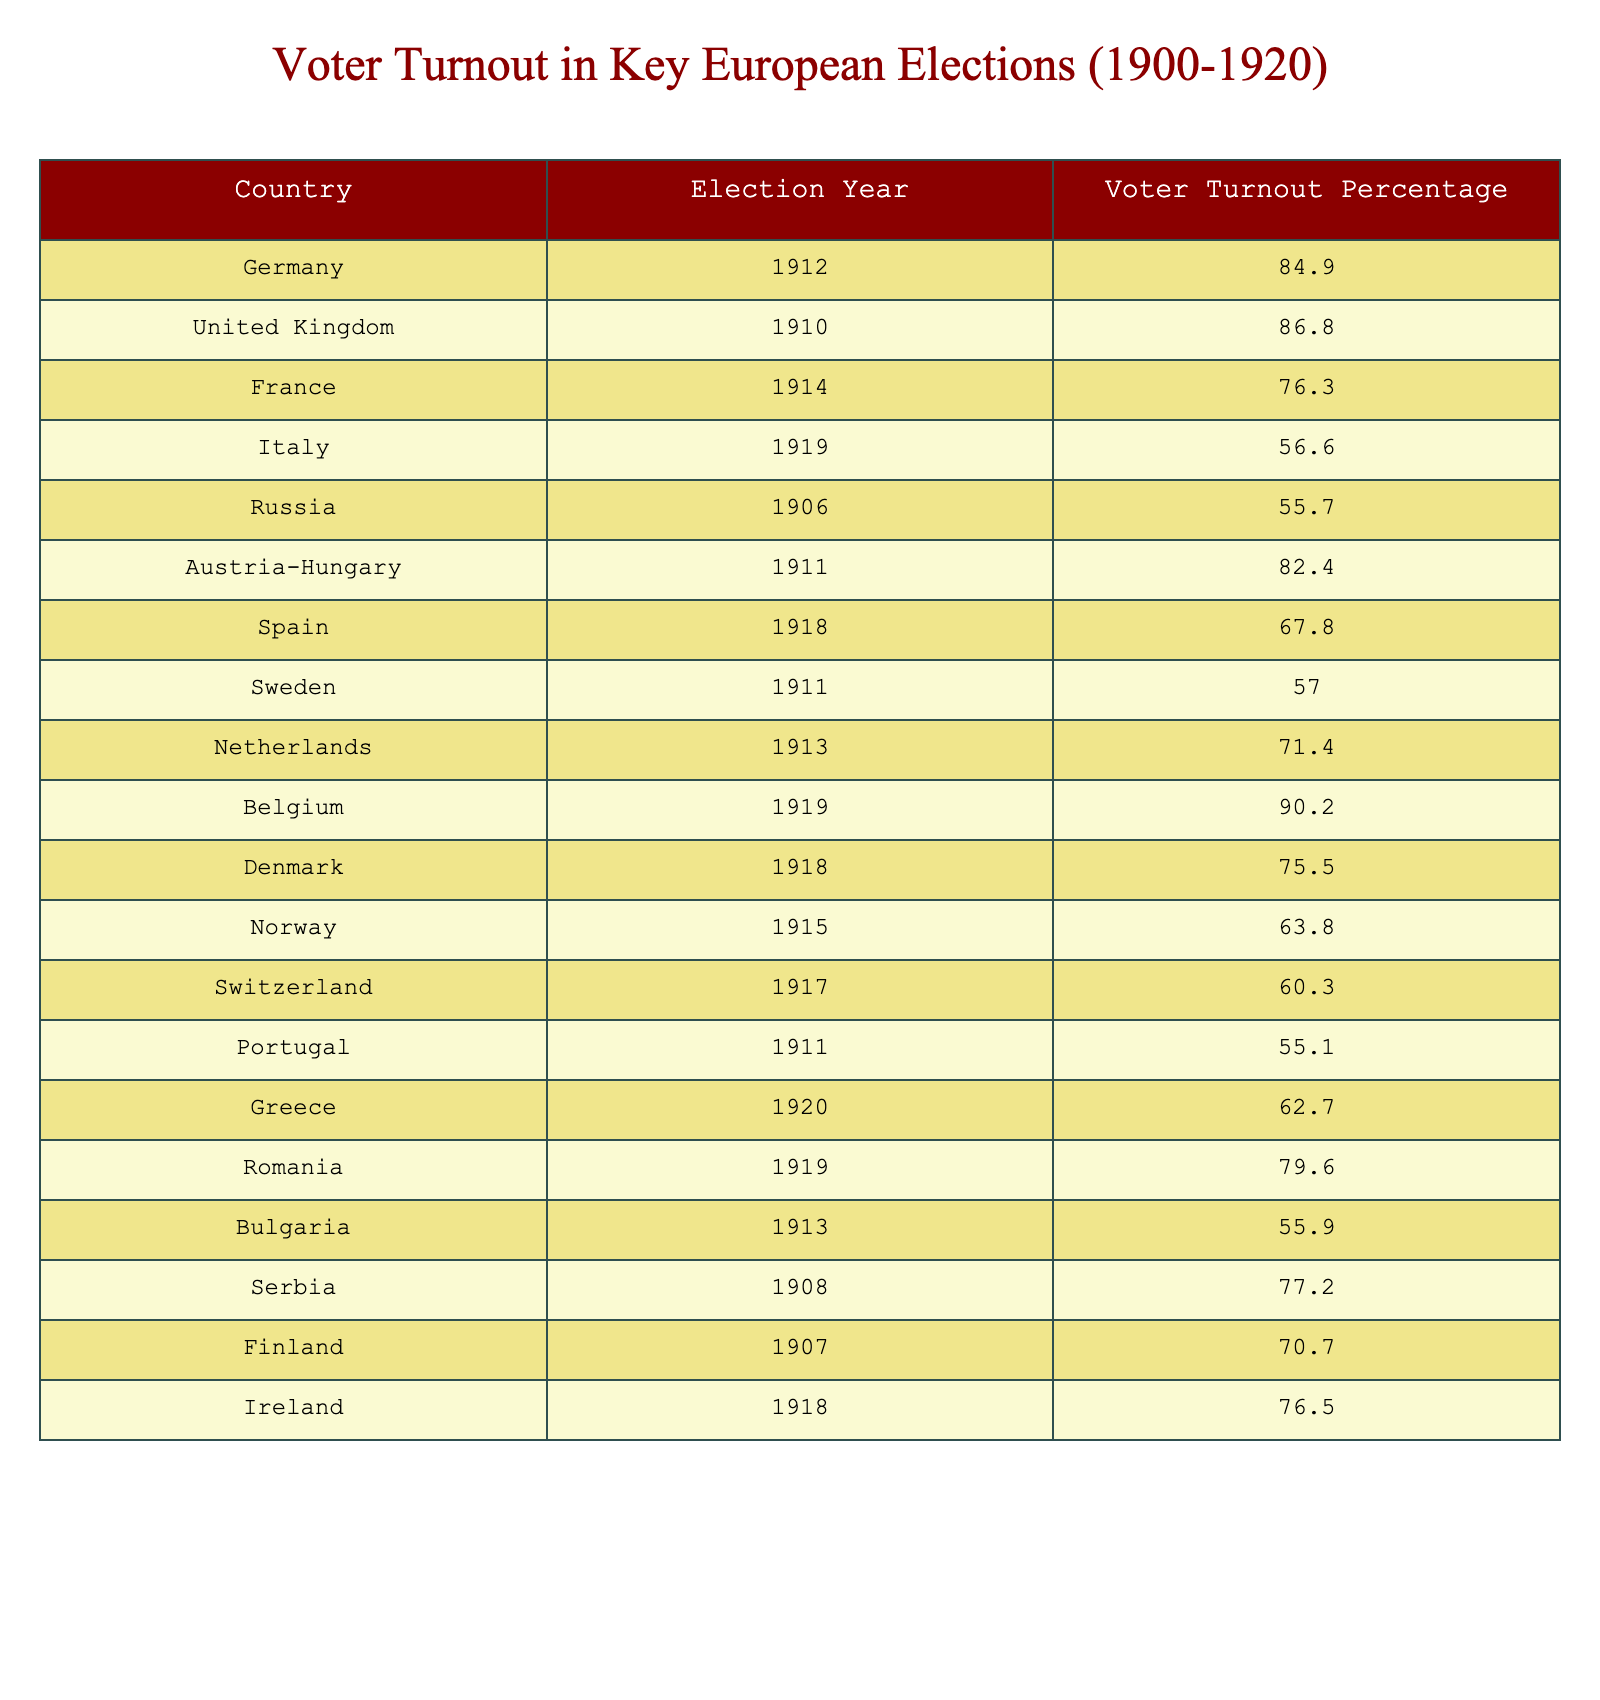What was the voter turnout percentage in Germany in 1912? The table shows that Germany had a voter turnout percentage of 84.9% in the year 1912.
Answer: 84.9% Which country had the highest voter turnout percentage in this period? The table indicates that Belgium had the highest voter turnout percentage of 90.2% in 1919.
Answer: Belgium (90.2%) What is the average voter turnout percentage for the elections listed? To find the average, sum all the voter turnout percentages (84.9 + 86.8 + 76.3 + 56.6 + 55.7 + 82.4 + 67.8 + 57.0 + 71.4 + 90.2 + 75.5 + 63.8 + 60.3 + 55.1 + 62.7 + 79.6 + 55.9 + 77.2 + 70.7 + 76.5), which equals 1,296.7, and divide by the number of entries (20). The average is approximately 64.84%.
Answer: Approximately 64.84% Did Italy's voter turnout in 1919 exceed that of Greece's in 1920? Italy's voter turnout was 56.6% in 1919, while Greece's in 1920 was 62.7%. Since 62.7% is greater than 56.6%, Italy's turnout did not exceed Greece's.
Answer: No What percentage of voters turned out in Spain in 1918 compared to Sweden in 1911? Spain had a voter turnout of 67.8% in 1918, while Sweden had 57.0% in 1911. To compare, 67.8% is greater than 57.0%, meaning Spain had a higher turnout than Sweden.
Answer: Spain had a higher turnout Which two countries had the closest voter turnout percentages, and what were they? After reviewing the table, the closest percentages are 55.7% for Russia in 1906 and 55.9% for Bulgaria in 1913, with a difference of only 0.2%.
Answer: Russia (55.7%) and Bulgaria (55.9%) What is the difference in voter turnout percentage between Switzerland in 1917 and Romania in 1919? Switzerland had a turnout of 60.3% in 1917, while Romania had 79.6% in 1919. The difference is calculated as 79.6% - 60.3% = 19.3%, indicating Romania had a significantly higher turnout.
Answer: 19.3% Were there any elections with a turnout below 60%? Reviewing the table shows that both Italy (56.6% in 1919) and Russia (55.7% in 1906) had turnouts below 60%. Thus, yes, there were elections with such turnout percentages.
Answer: Yes Which country had a higher turnout percentage, Austria-Hungary in 1911 or Denmark in 1918? Austria-Hungary had a turnout of 82.4% in 1911, while Denmark had 75.5% in 1918. Since 82.4% is greater than 75.5%, Austria-Hungary had a higher turnout.
Answer: Austria-Hungary 